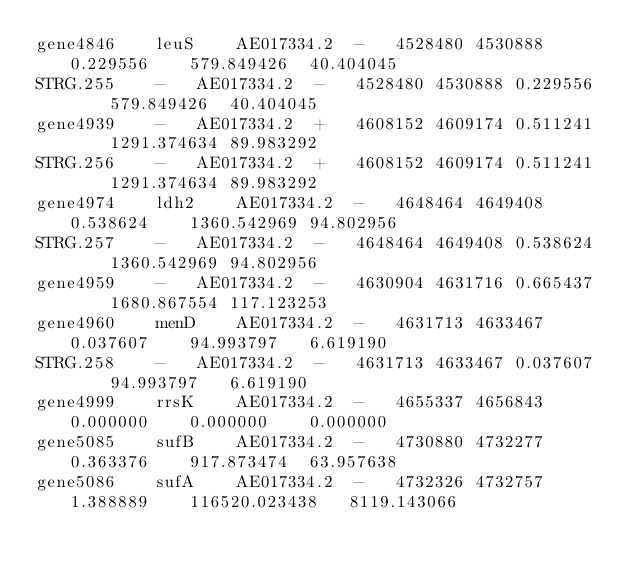<code> <loc_0><loc_0><loc_500><loc_500><_SQL_>gene4846	leuS	AE017334.2	-	4528480	4530888	0.229556	579.849426	40.404045
STRG.255	-	AE017334.2	-	4528480	4530888	0.229556	579.849426	40.404045
gene4939	-	AE017334.2	+	4608152	4609174	0.511241	1291.374634	89.983292
STRG.256	-	AE017334.2	+	4608152	4609174	0.511241	1291.374634	89.983292
gene4974	ldh2	AE017334.2	-	4648464	4649408	0.538624	1360.542969	94.802956
STRG.257	-	AE017334.2	-	4648464	4649408	0.538624	1360.542969	94.802956
gene4959	-	AE017334.2	-	4630904	4631716	0.665437	1680.867554	117.123253
gene4960	menD	AE017334.2	-	4631713	4633467	0.037607	94.993797	6.619190
STRG.258	-	AE017334.2	-	4631713	4633467	0.037607	94.993797	6.619190
gene4999	rrsK	AE017334.2	-	4655337	4656843	0.000000	0.000000	0.000000
gene5085	sufB	AE017334.2	-	4730880	4732277	0.363376	917.873474	63.957638
gene5086	sufA	AE017334.2	-	4732326	4732757	1.388889	116520.023438	8119.143066</code> 